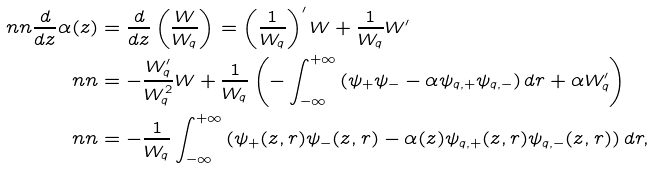Convert formula to latex. <formula><loc_0><loc_0><loc_500><loc_500>\ n n \frac { d } { d z } \alpha ( z ) & = \frac { d } { d z } \left ( \frac { W } { W _ { q } } \right ) = \left ( \frac { 1 } { W _ { q } } \right ) ^ { \prime } W + \frac { 1 } { W _ { q } } W ^ { \prime } \\ \ n n & = - \frac { W _ { q } ^ { \prime } } { W _ { q } ^ { 2 } } W + \frac { 1 } { W _ { q } } \left ( - \int _ { - \infty } ^ { + \infty } \left ( \psi _ { + } \psi _ { - } - \alpha \psi _ { q , + } \psi _ { q , - } \right ) d r + \alpha W _ { q } ^ { \prime } \right ) \\ \ n n & = - \frac { 1 } { W _ { q } } \int _ { - \infty } ^ { + \infty } \left ( \psi _ { + } ( z , r ) \psi _ { - } ( z , r ) - \alpha ( z ) \psi _ { q , + } ( z , r ) \psi _ { q , - } ( z , r ) \right ) d r ,</formula> 